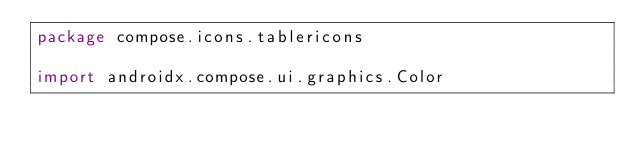Convert code to text. <code><loc_0><loc_0><loc_500><loc_500><_Kotlin_>package compose.icons.tablericons

import androidx.compose.ui.graphics.Color</code> 